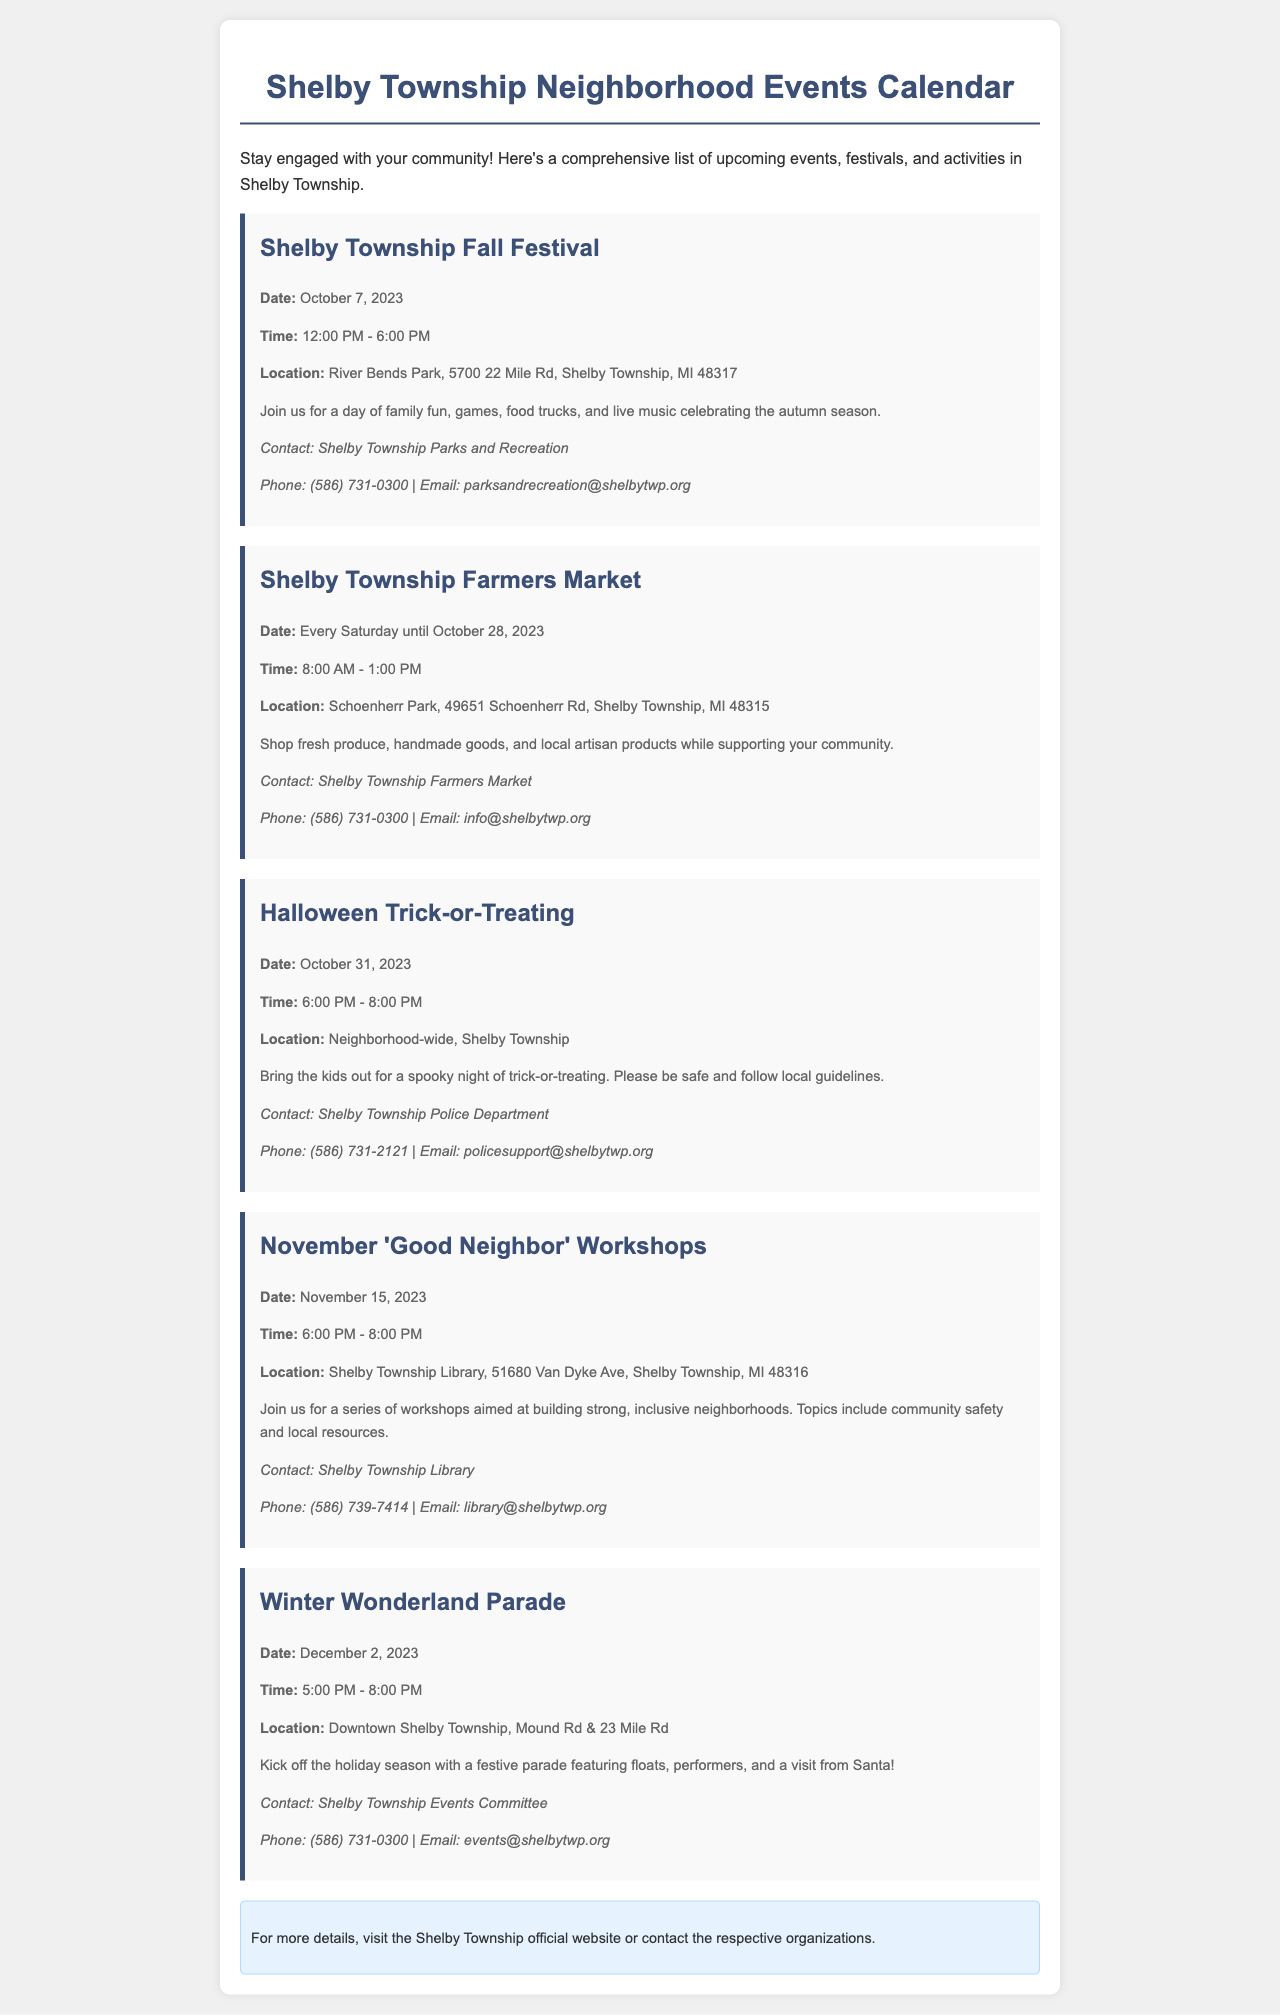What is the date of the Fall Festival? The Fall Festival is scheduled for October 7, 2023, as mentioned in the document.
Answer: October 7, 2023 How long does the Farmers Market run? The Farmers Market occurs every Saturday until October 28, 2023, which indicates its duration.
Answer: Until October 28, 2023 What is the time for Halloween Trick-or-Treating? The Halloween Trick-or-Treating is set for 6:00 PM to 8:00 PM according to the event details.
Answer: 6:00 PM - 8:00 PM Where is the Winter Wonderland Parade located? The Winter Wonderland Parade takes place at Downtown Shelby Township, specifically at Mound Rd & 23 Mile Rd.
Answer: Downtown Shelby Township, Mound Rd & 23 Mile Rd Who can be contacted for the November 'Good Neighbor' Workshops? The Shelby Township Library is the contact for the Good Neighbor Workshops event, as indicated in the contact information.
Answer: Shelby Township Library What type of activities will occur at the Fall Festival? The document describes the Fall Festival as having family fun, games, food trucks, and live music, which encompasses the types of activities.
Answer: Family fun, games, food trucks, live music Which organization is responsible for the Farmers Market? The contact information specifies that the Shelby Township Farmers Market is the responsible organization for the event details.
Answer: Shelby Township Farmers Market When does the Winter Wonderland Parade start? The Winter Wonderland Parade is set to start at 5:00 PM, as stated in the timing details of the event.
Answer: 5:00 PM 